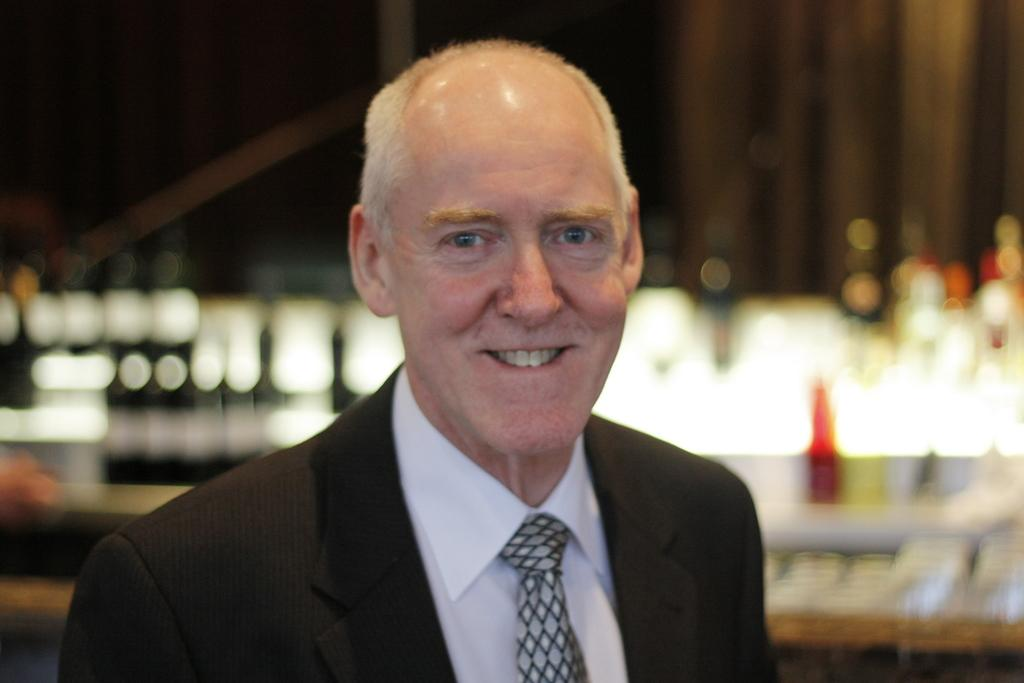Who is present in the image? There is a man in the image. What expression does the man have? The man is smiling. Can you describe the background of the image? The background of the image is blurred. What type of dinner is the man preparing in the image? There is no indication of a dinner or any food preparation in the image. 